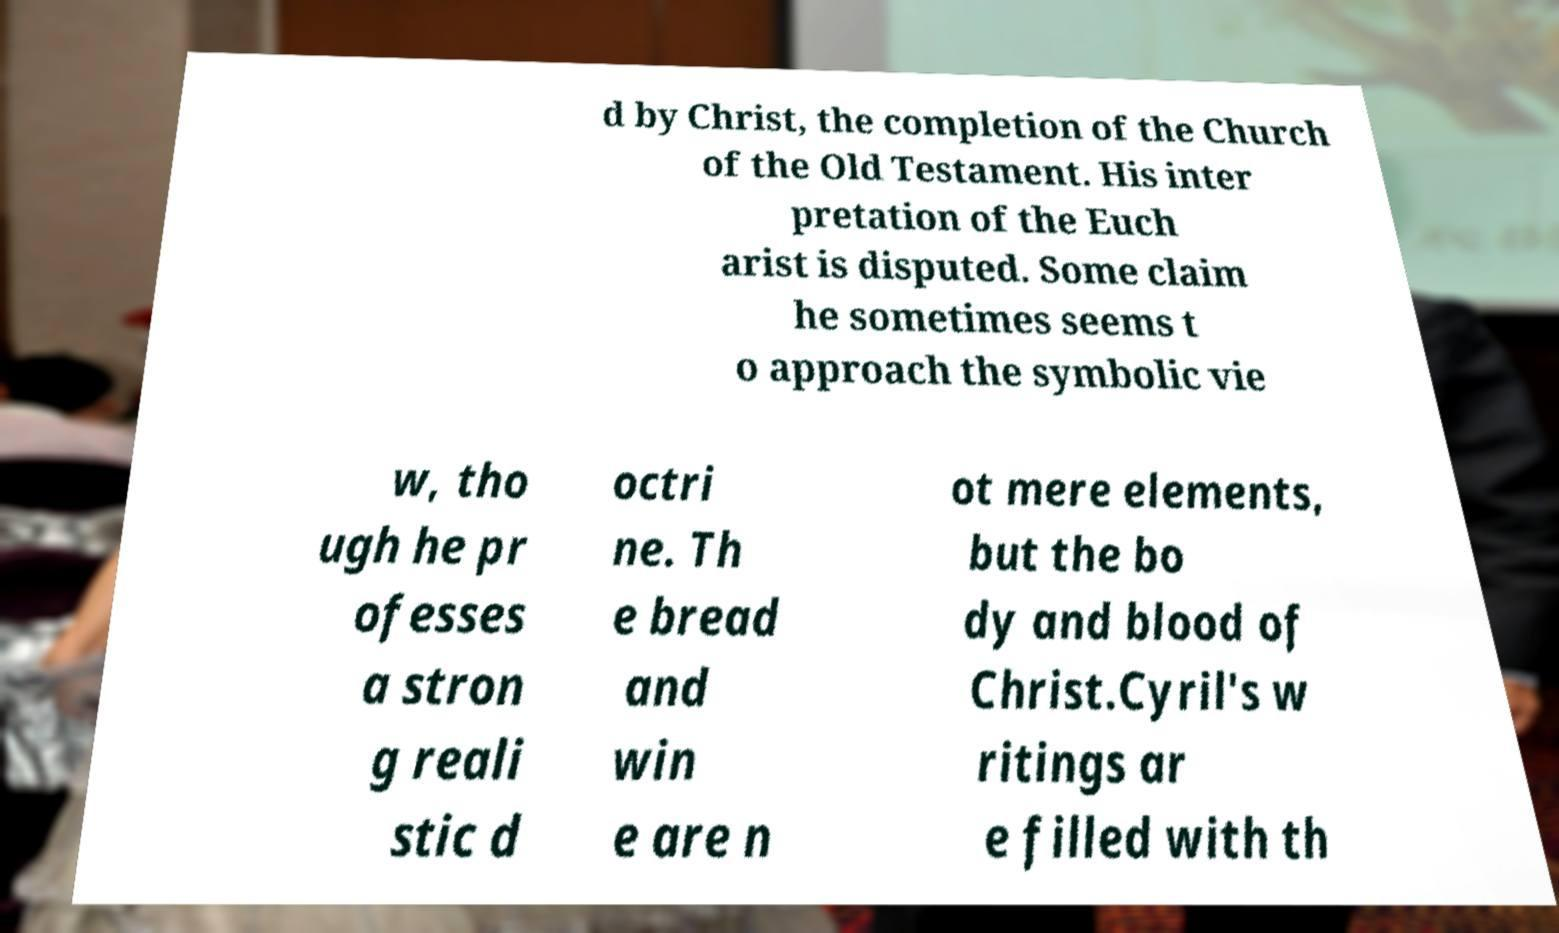Please read and relay the text visible in this image. What does it say? d by Christ, the completion of the Church of the Old Testament. His inter pretation of the Euch arist is disputed. Some claim he sometimes seems t o approach the symbolic vie w, tho ugh he pr ofesses a stron g reali stic d octri ne. Th e bread and win e are n ot mere elements, but the bo dy and blood of Christ.Cyril's w ritings ar e filled with th 